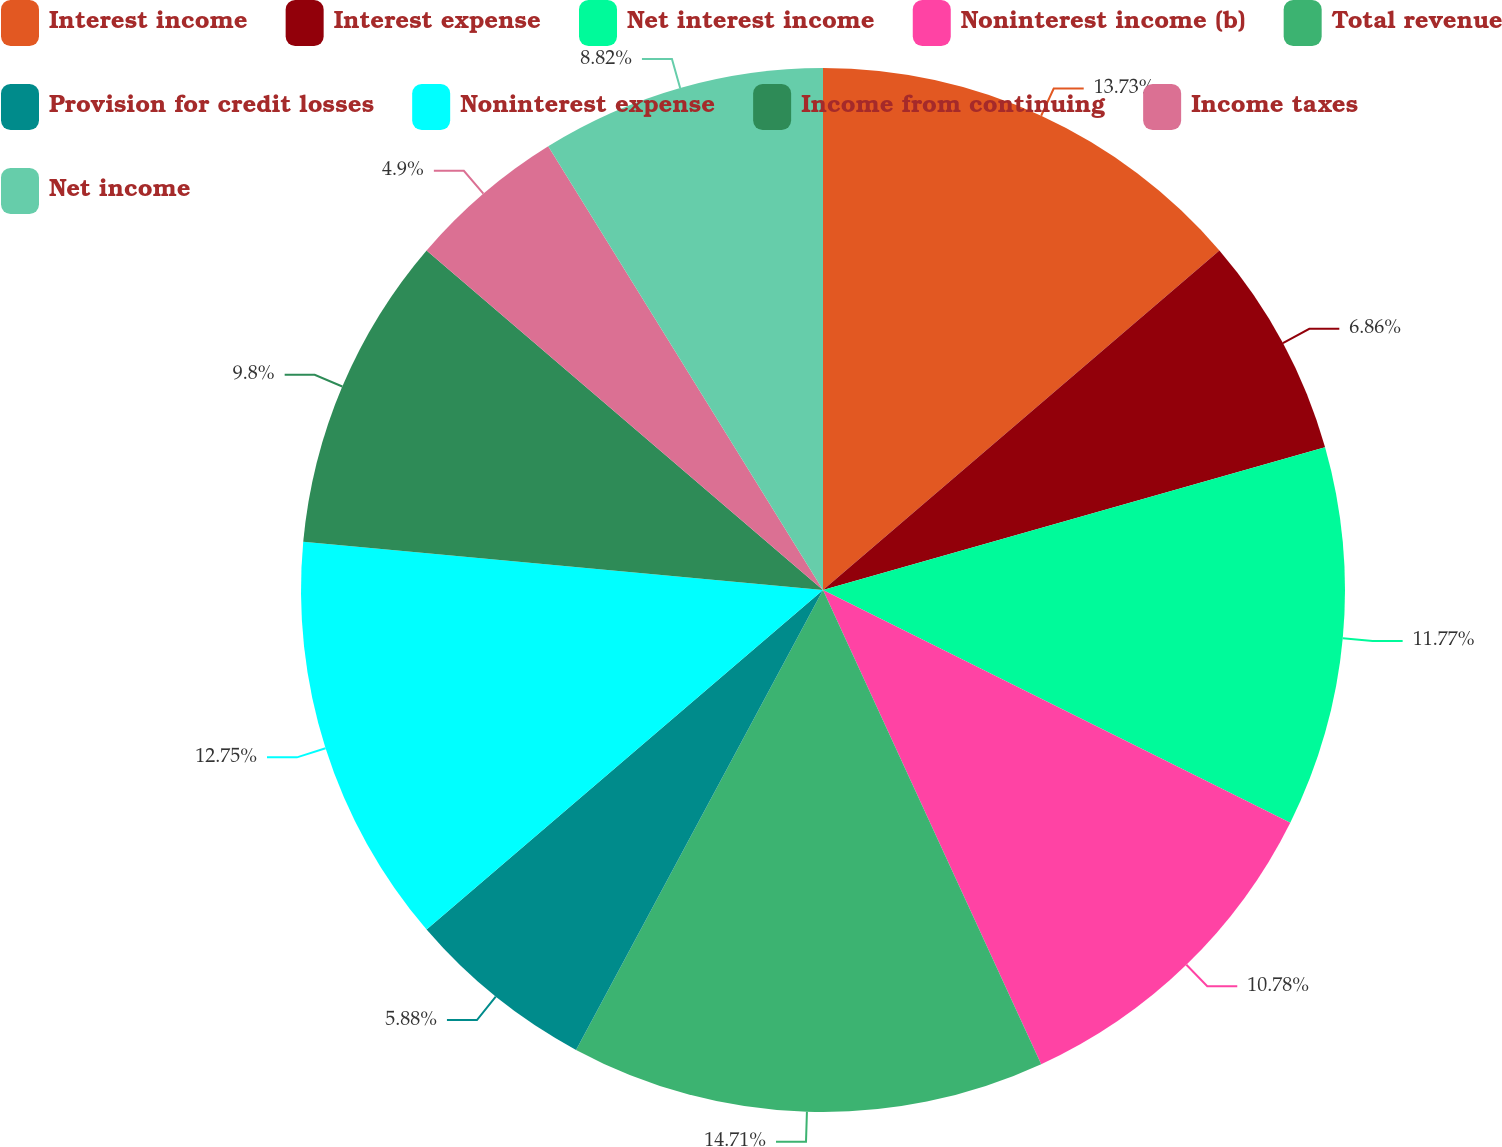<chart> <loc_0><loc_0><loc_500><loc_500><pie_chart><fcel>Interest income<fcel>Interest expense<fcel>Net interest income<fcel>Noninterest income (b)<fcel>Total revenue<fcel>Provision for credit losses<fcel>Noninterest expense<fcel>Income from continuing<fcel>Income taxes<fcel>Net income<nl><fcel>13.72%<fcel>6.86%<fcel>11.76%<fcel>10.78%<fcel>14.7%<fcel>5.88%<fcel>12.74%<fcel>9.8%<fcel>4.9%<fcel>8.82%<nl></chart> 